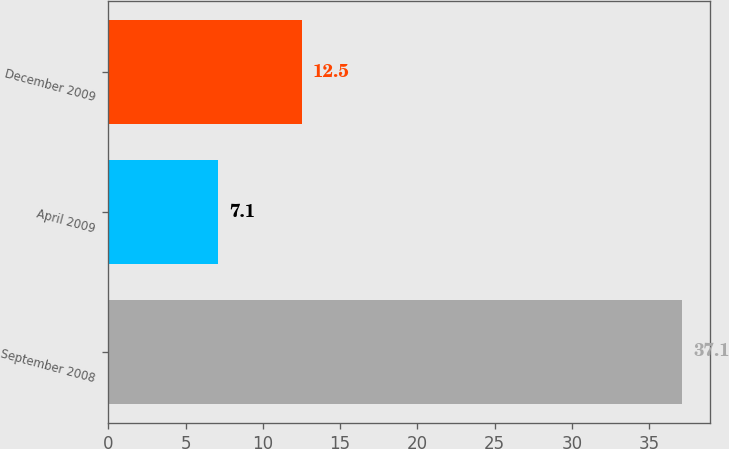Convert chart to OTSL. <chart><loc_0><loc_0><loc_500><loc_500><bar_chart><fcel>September 2008<fcel>April 2009<fcel>December 2009<nl><fcel>37.1<fcel>7.1<fcel>12.5<nl></chart> 